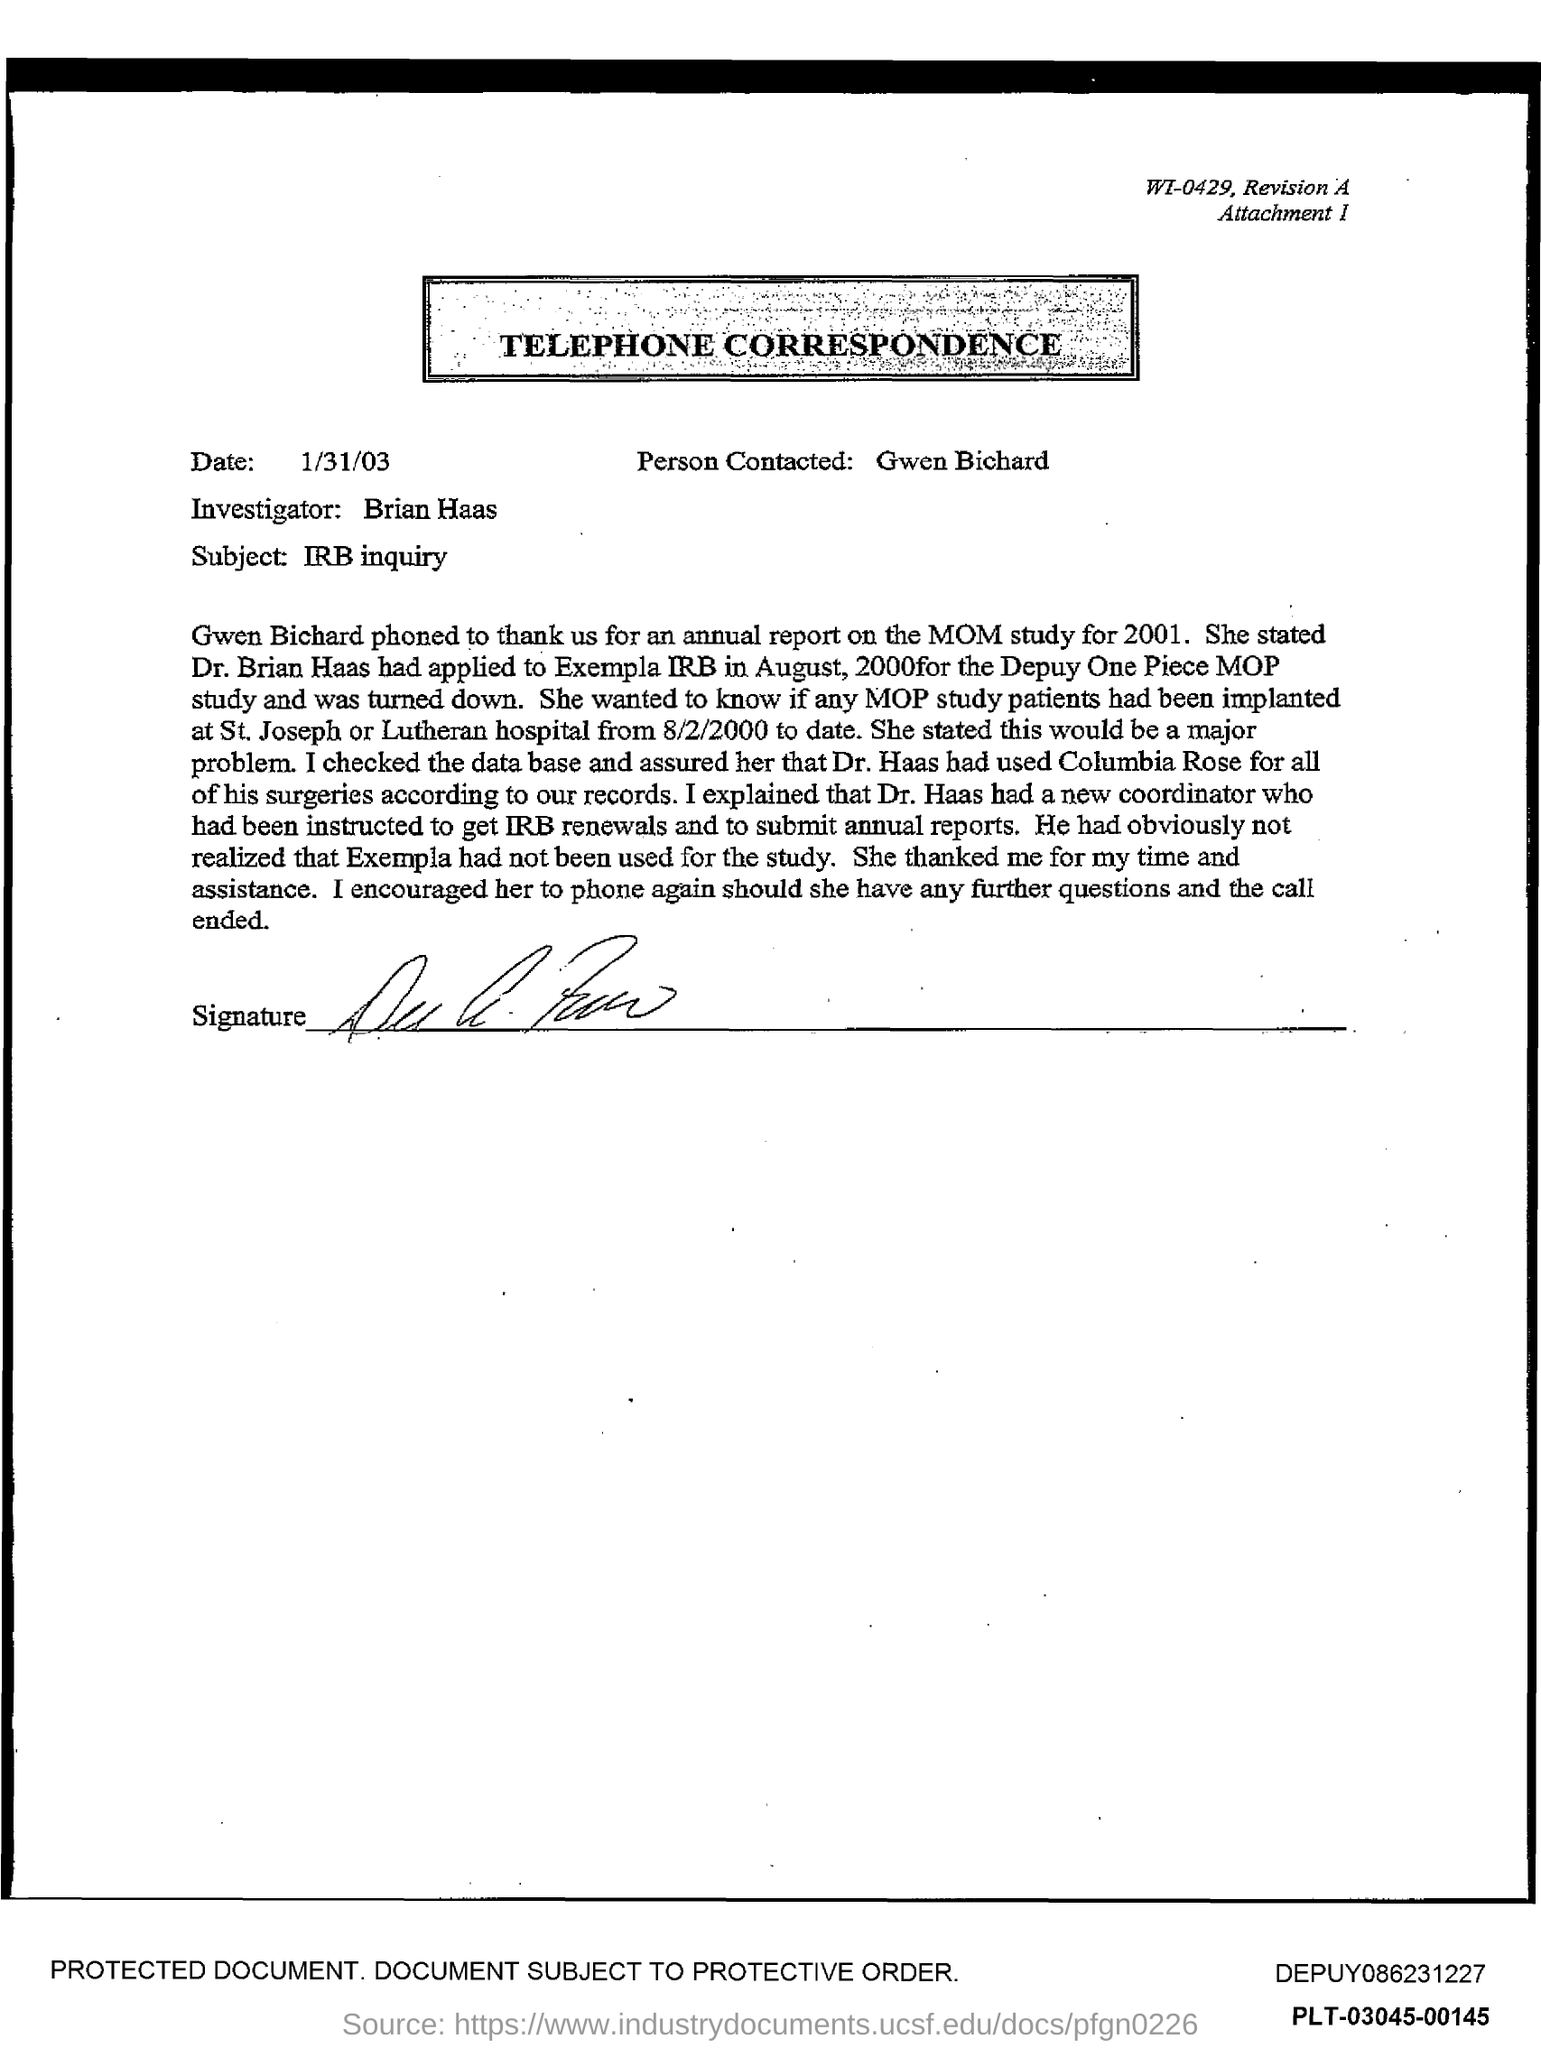Outline some significant characteristics in this image. The subject of the telephone correspondence is an IRB inquiry. The date of the telephone correspondence is January 31, 2003. This is telephone correspondence. Brian Haas is the investigator mentioned in the correspondence. Gwen Bichard is the person who was contacted. 